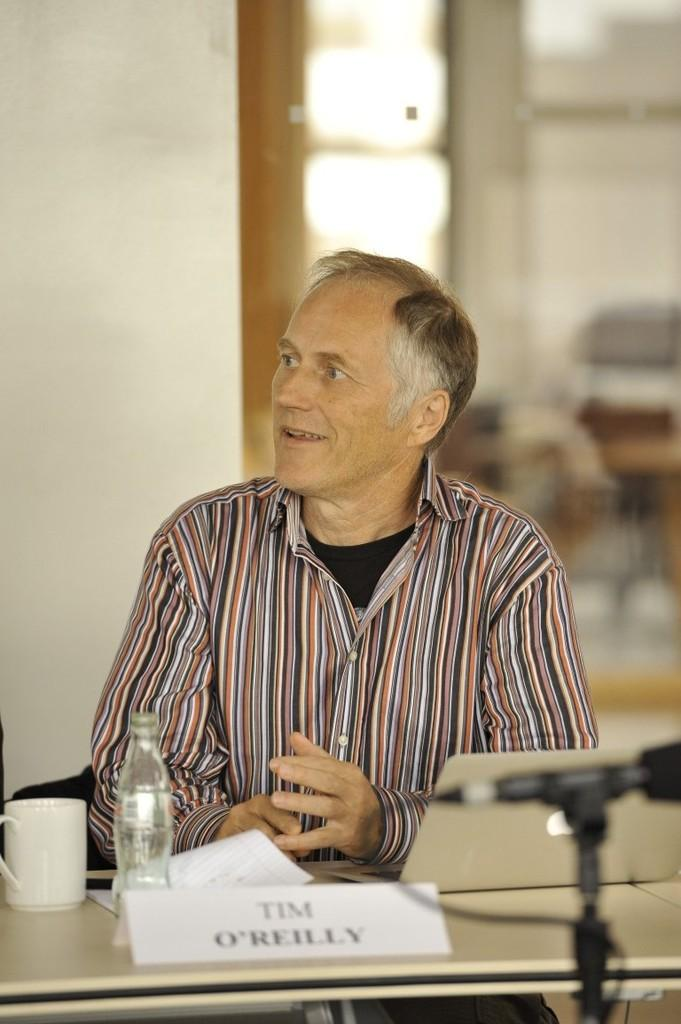What is the person in the image doing? There is a person sitting in the image. What is the person wearing? The person is wearing a black shirt. What object is in front of the person? There is a bottle in front of the person. What can be seen on the table in the image? There are papers on the table. Can you describe the background of the image? The background of the image is blurred. What type of lace is used to decorate the person's shirt in the image? There is no lace visible on the person's shirt in the image; they are wearing a black shirt. 